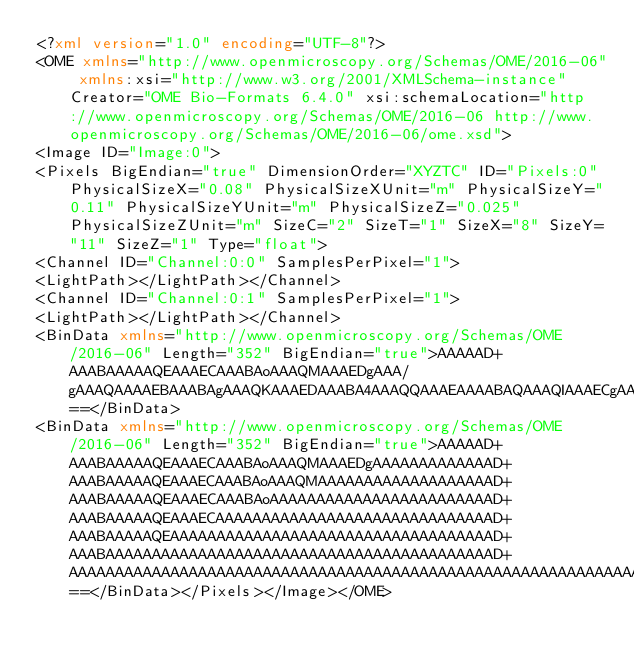<code> <loc_0><loc_0><loc_500><loc_500><_XML_><?xml version="1.0" encoding="UTF-8"?>
<OME xmlns="http://www.openmicroscopy.org/Schemas/OME/2016-06" xmlns:xsi="http://www.w3.org/2001/XMLSchema-instance" Creator="OME Bio-Formats 6.4.0" xsi:schemaLocation="http://www.openmicroscopy.org/Schemas/OME/2016-06 http://www.openmicroscopy.org/Schemas/OME/2016-06/ome.xsd">
<Image ID="Image:0">
<Pixels BigEndian="true" DimensionOrder="XYZTC" ID="Pixels:0" PhysicalSizeX="0.08" PhysicalSizeXUnit="m" PhysicalSizeY="0.11" PhysicalSizeYUnit="m" PhysicalSizeZ="0.025" PhysicalSizeZUnit="m" SizeC="2" SizeT="1" SizeX="8" SizeY="11" SizeZ="1" Type="float">
<Channel ID="Channel:0:0" SamplesPerPixel="1">
<LightPath></LightPath></Channel>
<Channel ID="Channel:0:1" SamplesPerPixel="1">
<LightPath></LightPath></Channel>
<BinData xmlns="http://www.openmicroscopy.org/Schemas/OME/2016-06" Length="352" BigEndian="true">AAAAAD+AAABAAAAAQEAAAECAAABAoAAAQMAAAEDgAAA/gAAAQAAAAEBAAABAgAAAQKAAAEDAAABA4AAAQQAAAEAAAABAQAAAQIAAAECgAABAwAAAQOAAAEEAAABBEAAAQEAAAECAAABAoAAAQMAAAEDgAABBAAAAQRAAAEEgAABAgAAAQKAAAEDAAABA4AAAQQAAAEEQAABBIAAAQTAAAECgAABAwAAAQOAAAEEAAABBEAAAQSAAAEEwAABBQAAAQMAAAEDgAABBAAAAQRAAAEEgAABBMAAAQUAAAEFQAABA4AAAQQAAAEEQAABBIAAAQTAAAEFAAABBUAAAQWAAAEEAAABBEAAAQSAAAEEwAABBQAAAQVAAAEFgAABBcAAAQRAAAEEgAABBMAAAQUAAAEFQAABBYAAAQXAAAEGAAABBIAAAQTAAAEFAAABBUAAAQWAAAEFwAABBgAAAQYgAAA==</BinData>
<BinData xmlns="http://www.openmicroscopy.org/Schemas/OME/2016-06" Length="352" BigEndian="true">AAAAAD+AAABAAAAAQEAAAECAAABAoAAAQMAAAEDgAAAAAAAAAAAAAD+AAABAAAAAQEAAAECAAABAoAAAQMAAAAAAAAAAAAAAAAAAAD+AAABAAAAAQEAAAECAAABAoAAAAAAAAAAAAAAAAAAAAAAAAD+AAABAAAAAQEAAAECAAAAAAAAAAAAAAAAAAAAAAAAAAAAAAD+AAABAAAAAQEAAAAAAAAAAAAAAAAAAAAAAAAAAAAAAAAAAAD+AAABAAAAAAAAAAAAAAAAAAAAAAAAAAAAAAAAAAAAAAAAAAD+AAAAAAAAAAAAAAAAAAAAAAAAAAAAAAAAAAAAAAAAAAAAAAAAAAAAAAAAAAAAAAAAAAAAAAAAAAAAAAAAAAAAAAAAAAAAAAAAAAAAAAAAAAAAAAAAAAAAAAAAAAAAAAAAAAAAAAAAAAAAAAAAAAAAAAAAAAAAAAAAAAAAAAAAAAAAAAA==</BinData></Pixels></Image></OME></code> 